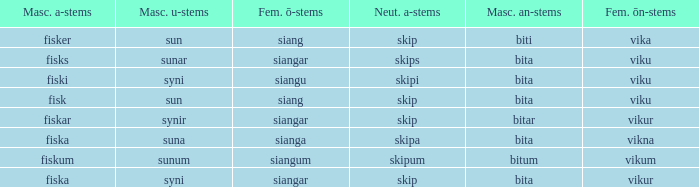What ending does siangu get for ön? Viku. 